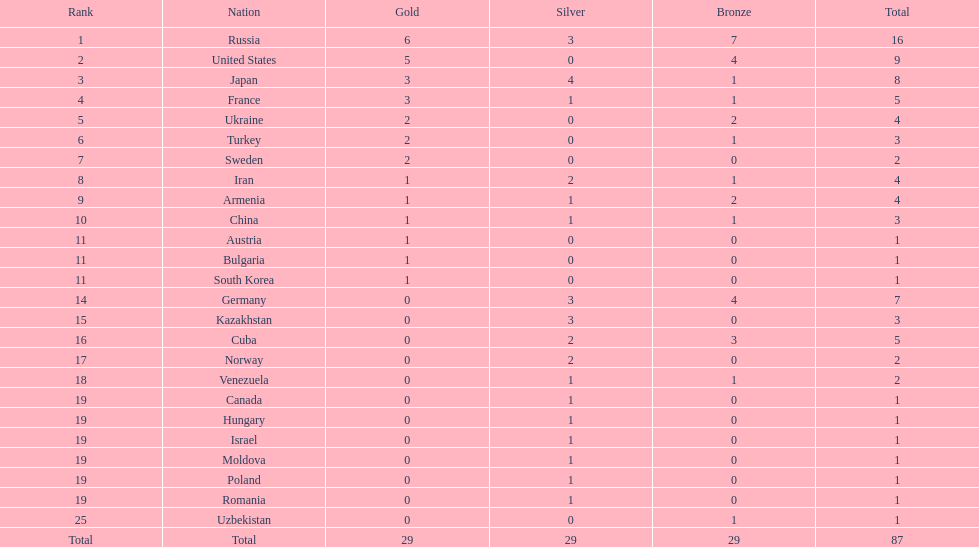Who came directly after turkey in ranking? Sweden. 